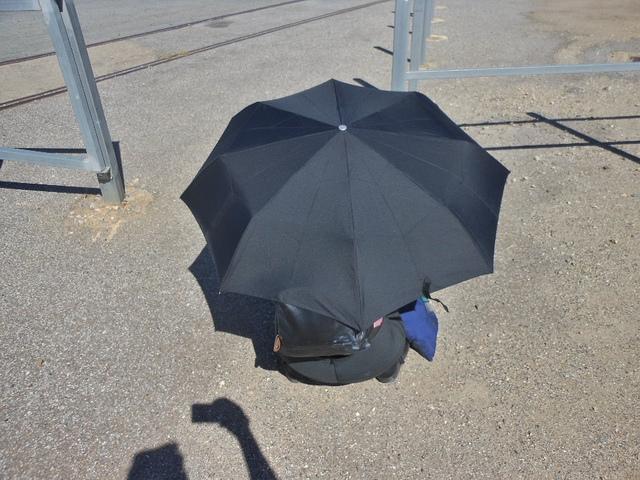Why does the photographer cast a shadow?
From the following four choices, select the correct answer to address the question.
Options: Takes photo, reflects light, blocks light, avoids light. Blocks light. 